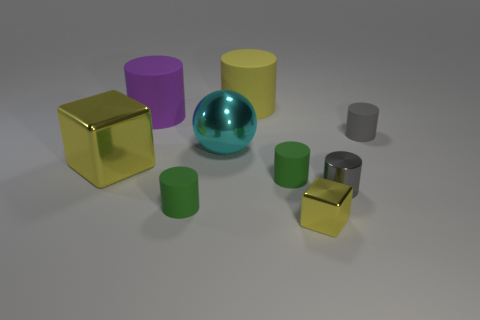Subtract all green cylinders. How many cylinders are left? 4 Subtract all green cylinders. How many cylinders are left? 4 Subtract all blue cylinders. Subtract all yellow spheres. How many cylinders are left? 6 Subtract all cubes. How many objects are left? 7 Subtract all tiny things. Subtract all shiny balls. How many objects are left? 3 Add 5 big yellow things. How many big yellow things are left? 7 Add 6 red matte things. How many red matte things exist? 6 Subtract 0 purple spheres. How many objects are left? 9 